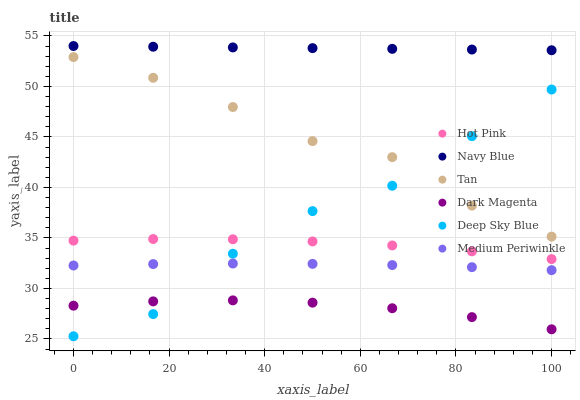Does Dark Magenta have the minimum area under the curve?
Answer yes or no. Yes. Does Navy Blue have the maximum area under the curve?
Answer yes or no. Yes. Does Hot Pink have the minimum area under the curve?
Answer yes or no. No. Does Hot Pink have the maximum area under the curve?
Answer yes or no. No. Is Navy Blue the smoothest?
Answer yes or no. Yes. Is Deep Sky Blue the roughest?
Answer yes or no. Yes. Is Hot Pink the smoothest?
Answer yes or no. No. Is Hot Pink the roughest?
Answer yes or no. No. Does Deep Sky Blue have the lowest value?
Answer yes or no. Yes. Does Hot Pink have the lowest value?
Answer yes or no. No. Does Navy Blue have the highest value?
Answer yes or no. Yes. Does Hot Pink have the highest value?
Answer yes or no. No. Is Dark Magenta less than Navy Blue?
Answer yes or no. Yes. Is Hot Pink greater than Dark Magenta?
Answer yes or no. Yes. Does Dark Magenta intersect Deep Sky Blue?
Answer yes or no. Yes. Is Dark Magenta less than Deep Sky Blue?
Answer yes or no. No. Is Dark Magenta greater than Deep Sky Blue?
Answer yes or no. No. Does Dark Magenta intersect Navy Blue?
Answer yes or no. No. 